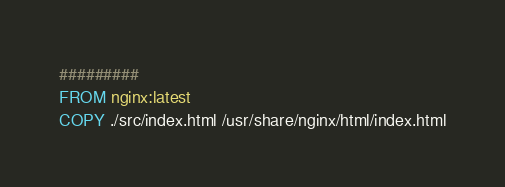Convert code to text. <code><loc_0><loc_0><loc_500><loc_500><_Dockerfile_>#########
FROM nginx:latest
COPY ./src/index.html /usr/share/nginx/html/index.html
</code> 